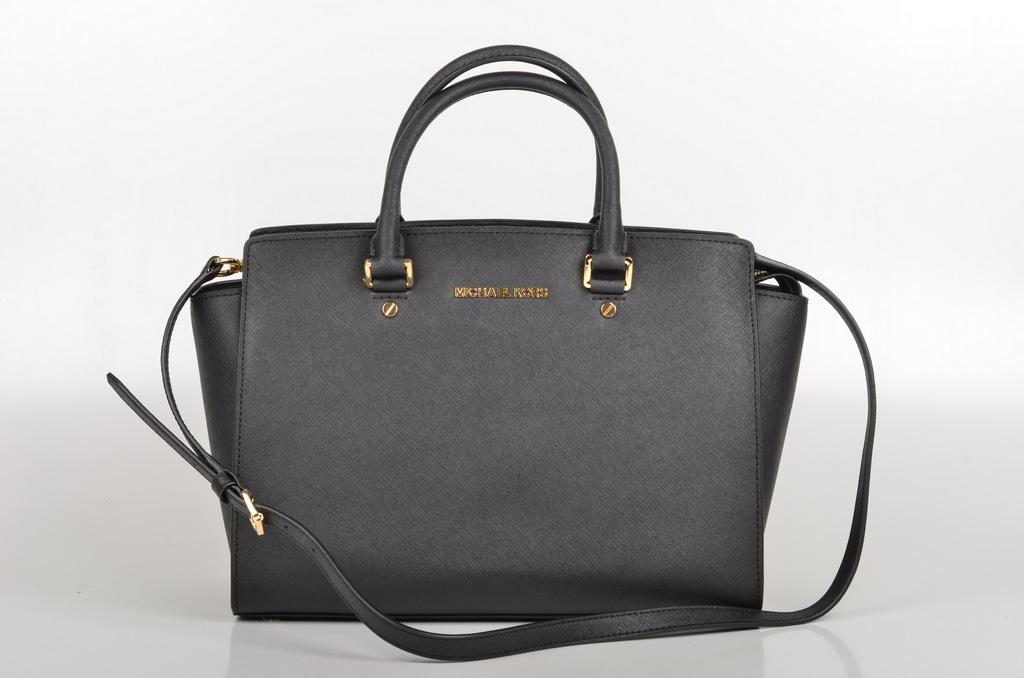What type of accessory is visible in the image? There is a handbag in the image. What year is the home in the image built? There is no home present in the image, only a handbag. 